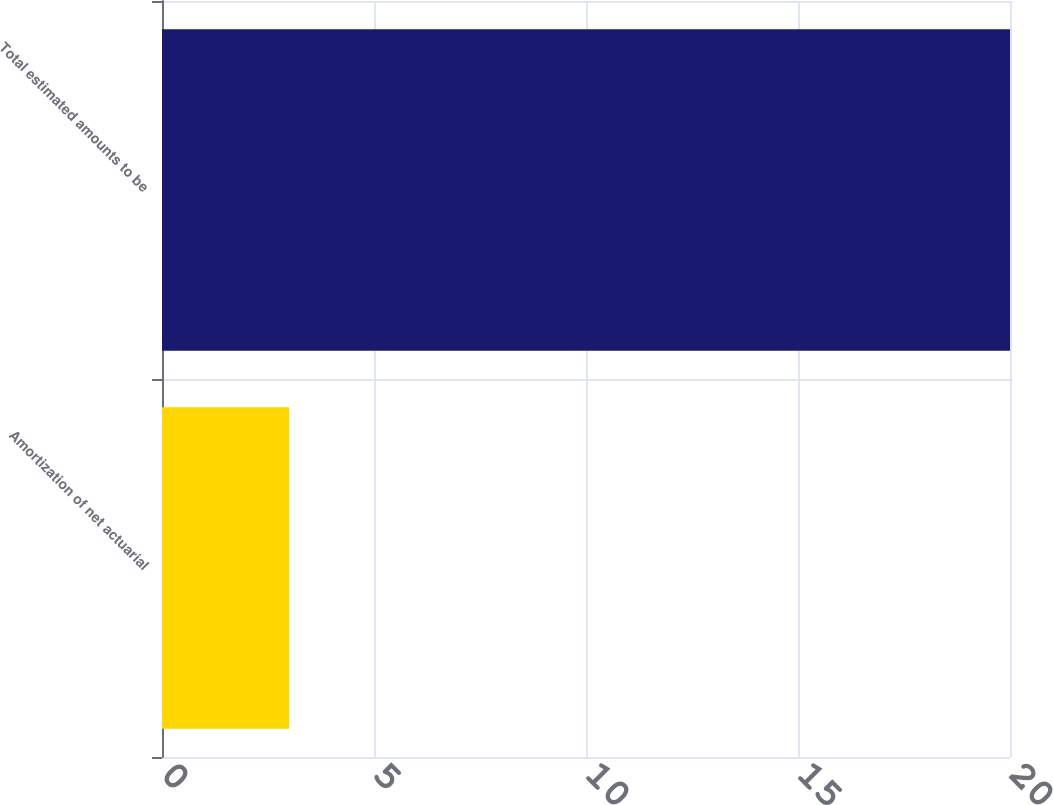Convert chart to OTSL. <chart><loc_0><loc_0><loc_500><loc_500><bar_chart><fcel>Amortization of net actuarial<fcel>Total estimated amounts to be<nl><fcel>3<fcel>20<nl></chart> 